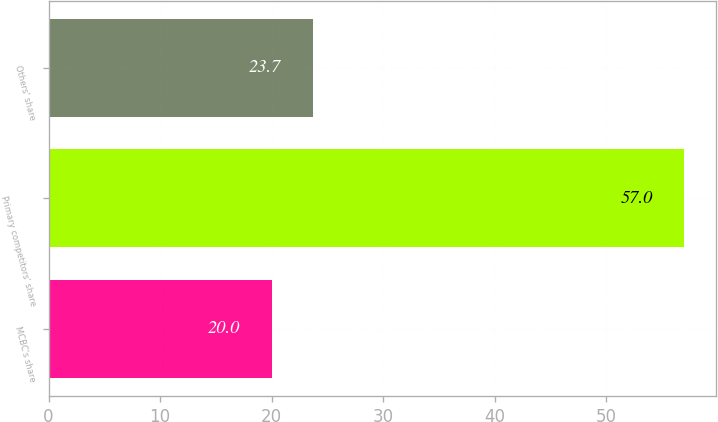<chart> <loc_0><loc_0><loc_500><loc_500><bar_chart><fcel>MCBC's share<fcel>Primary competitors' share<fcel>Others' share<nl><fcel>20<fcel>57<fcel>23.7<nl></chart> 